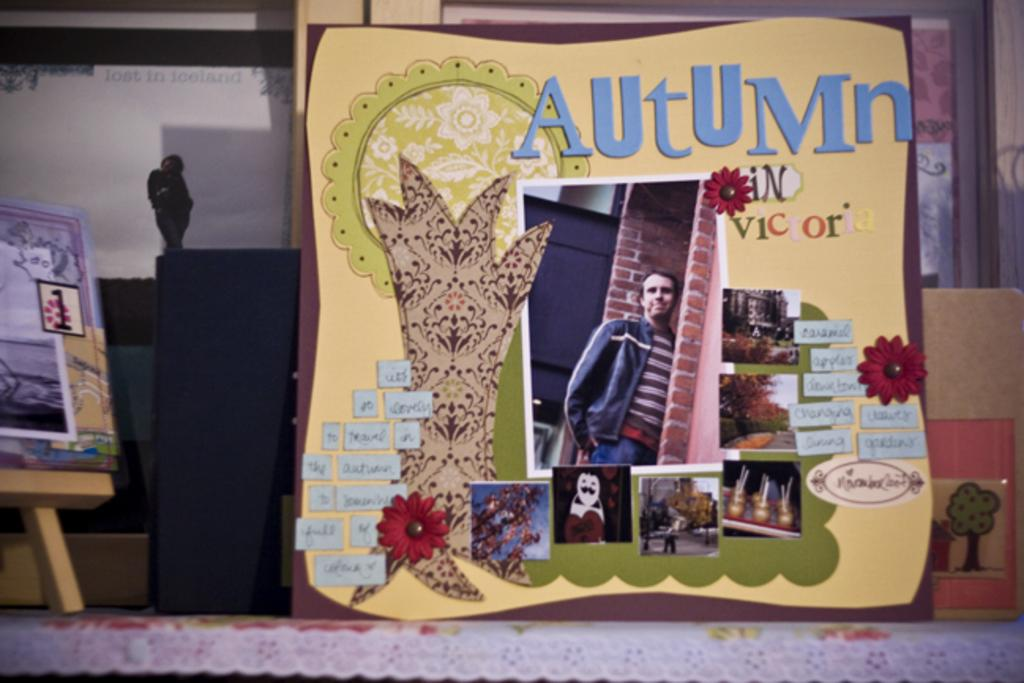<image>
Create a compact narrative representing the image presented. The word Autumn appears above a picture of a man. 